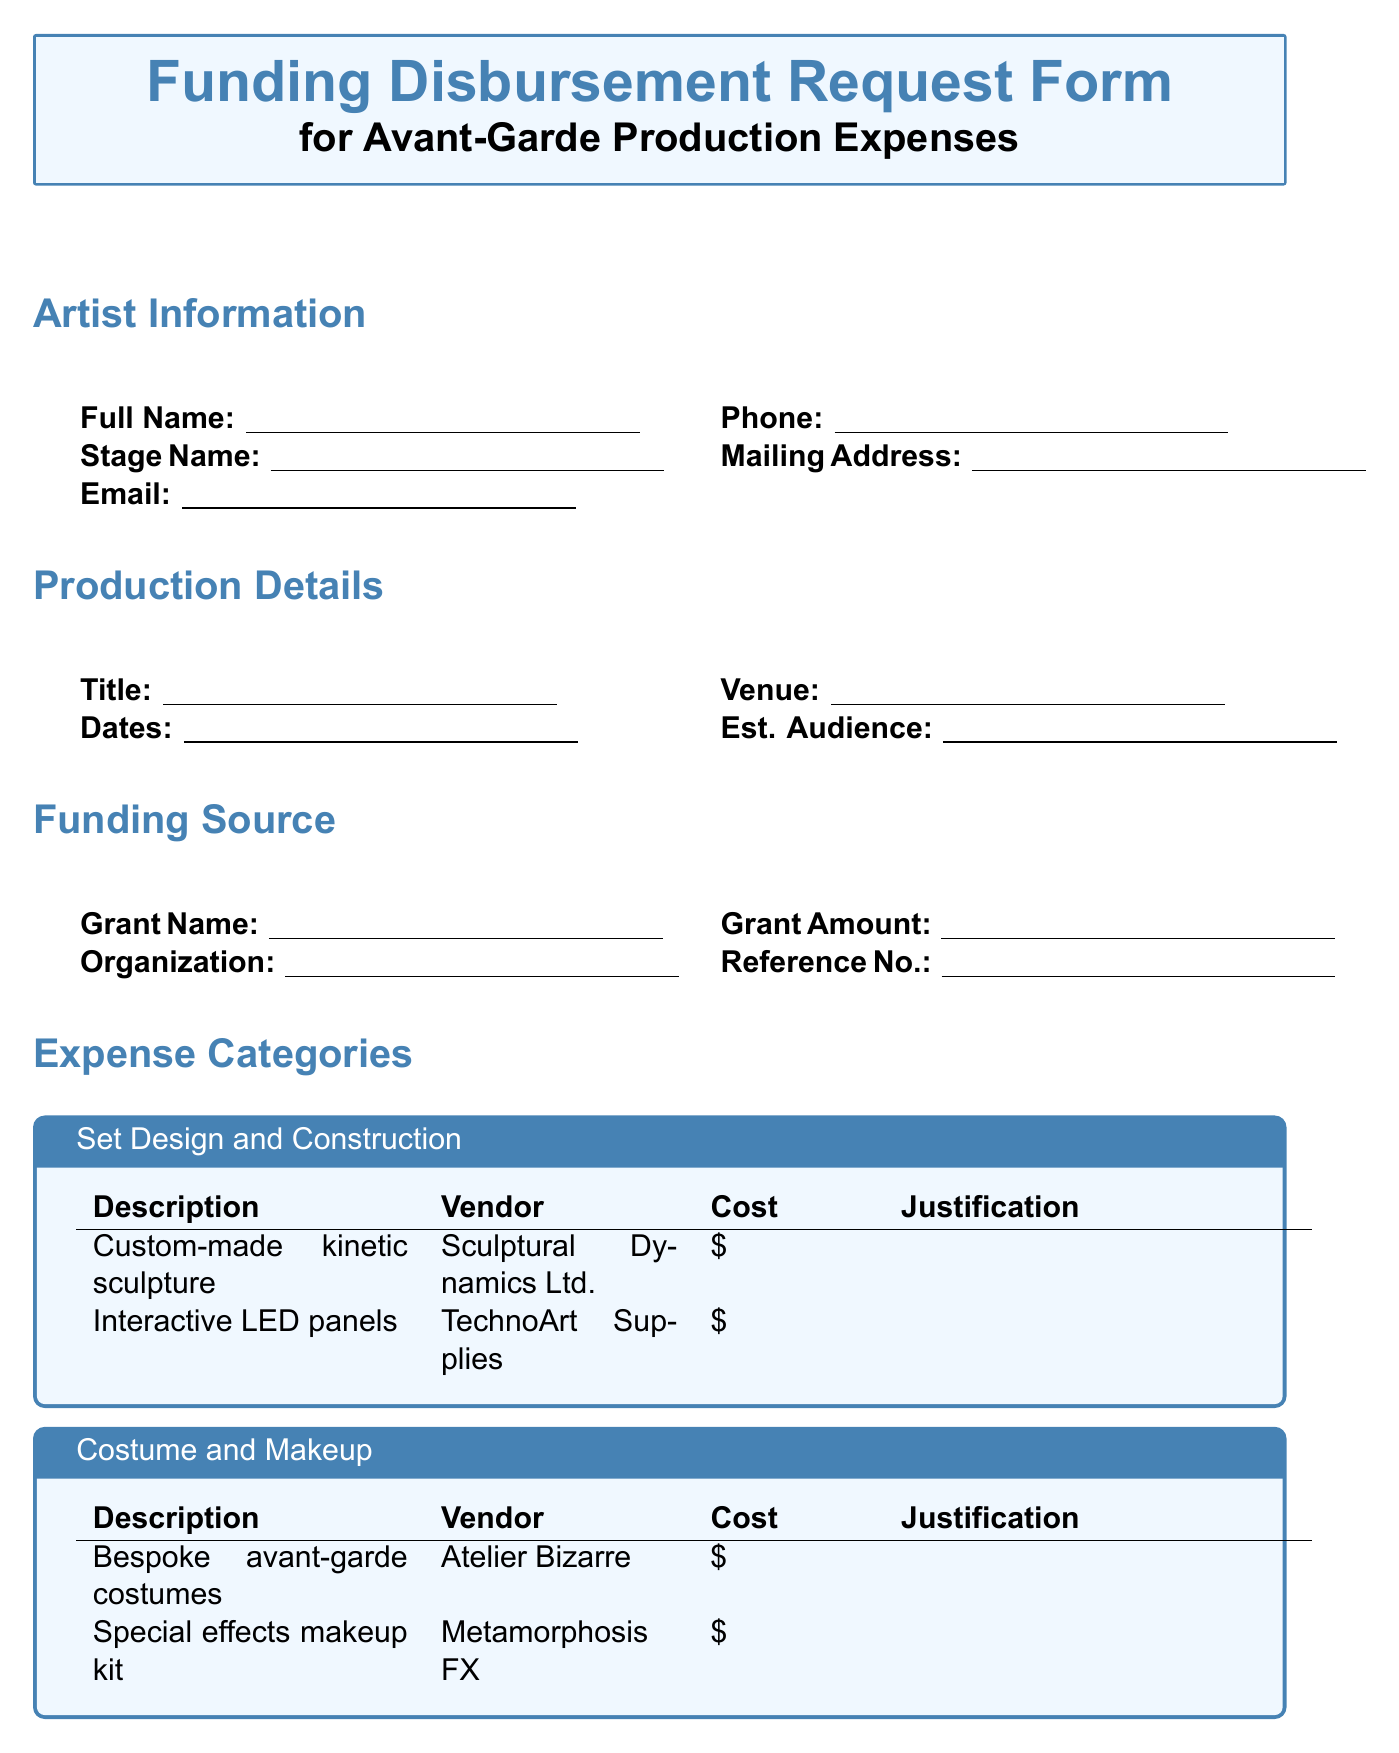What is the artist's full name? The document requests the artist's full name under the Artist Information section.
Answer: Full Name What is the title of the performance? The title of the avant-garde performance is specified in the Production Details section.
Answer: Title of Avant-Garde Performance Who is the vendor for the custom-made kinetic sculpture? The vendor for the custom-made kinetic sculpture can be found in the Set Design and Construction category.
Answer: Sculptural Dynamics Ltd What is the total grant amount awarded? The total grant amount awarded is listed under the Funding Source section in the form.
Answer: Total Grant Amount Awarded What type of equipment is being rented for audio-visual purposes? The document outlines the types of audio-visual equipment being rented in the corresponding section.
Answer: Surround sound system rental What is the payment information section requiring? The payment information section requires details for processing payments including account information.
Answer: Account Number What additional documents are required? The form specifies a list of required additional documents at the end of the document.
Answer: Detailed production concept What is the significance of certifying the information provided? The certification statement emphasizes the importance of accuracy in the provided information for funding purposes.
Answer: Funding eligibility What performance aspect is covered by the music licensing fees? The music licensing fees relate to the performance rights required for the music used in the production.
Answer: Performance rights 